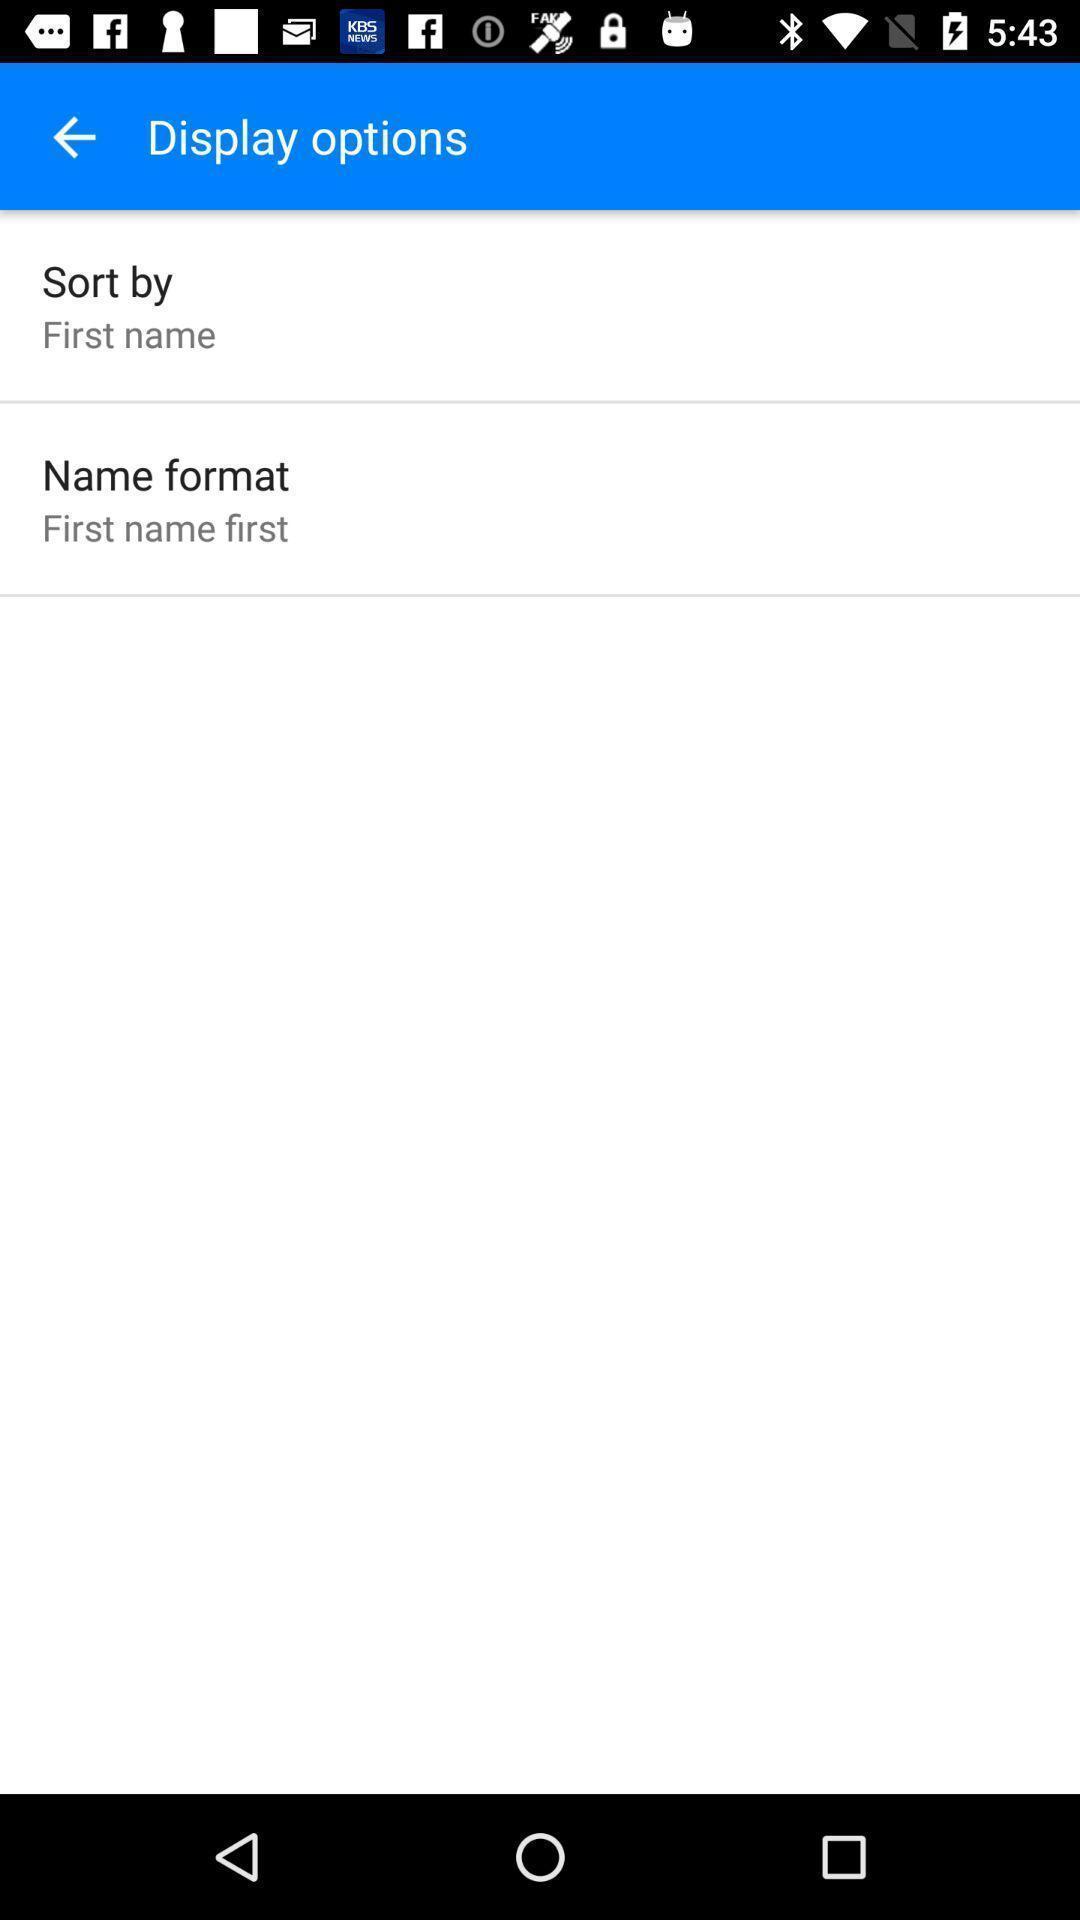Give me a narrative description of this picture. Page showing different options in display. 